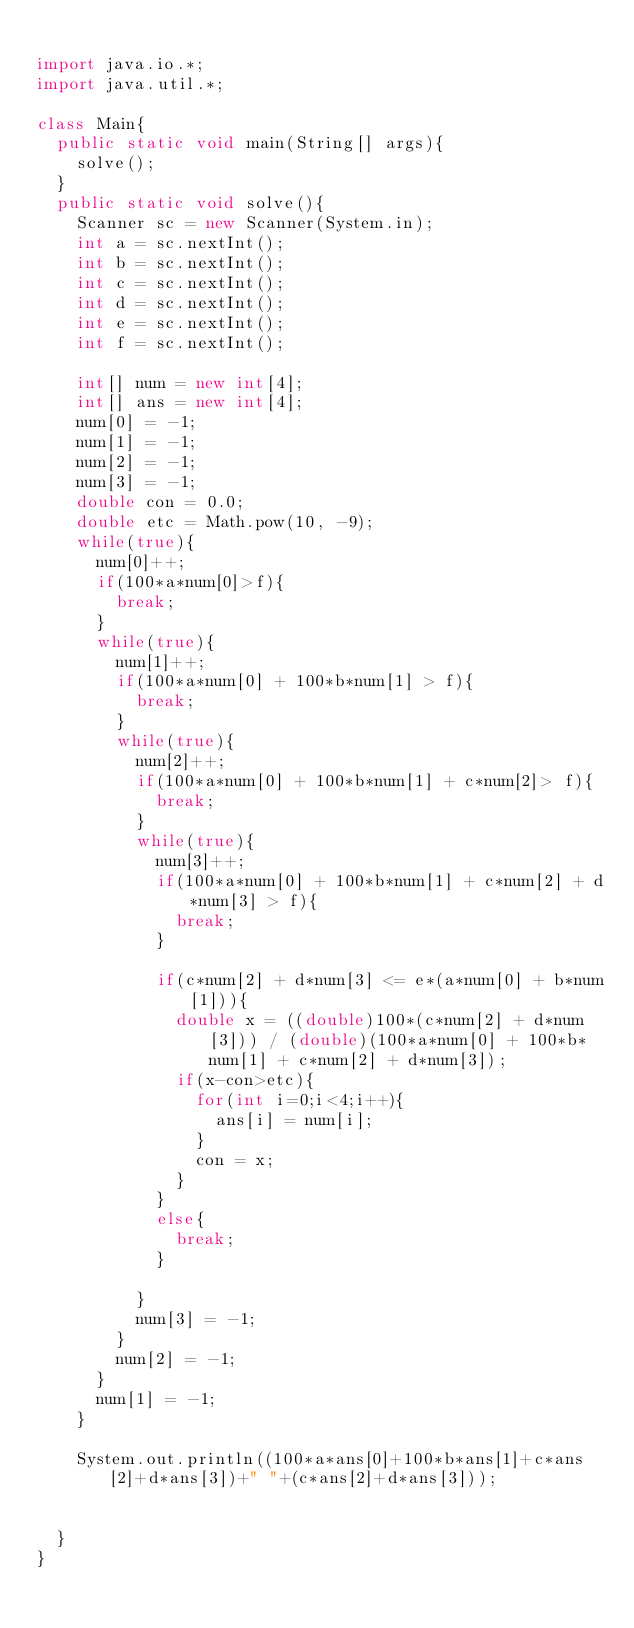<code> <loc_0><loc_0><loc_500><loc_500><_Java_>
import java.io.*;
import java.util.*;

class Main{
	public static void main(String[] args){
		solve();
	}
	public static void solve(){
		Scanner sc = new Scanner(System.in);
		int a = sc.nextInt();
		int b = sc.nextInt();
		int c = sc.nextInt();
		int d = sc.nextInt();
		int e = sc.nextInt();
		int f = sc.nextInt();

		int[] num = new int[4];
		int[] ans = new int[4];
		num[0] = -1;
		num[1] = -1;
		num[2] = -1;
		num[3] = -1;
		double con = 0.0;
		double etc = Math.pow(10, -9);
		while(true){
			num[0]++;
			if(100*a*num[0]>f){
				break;
			}
			while(true){
				num[1]++;
				if(100*a*num[0] + 100*b*num[1] > f){
					break;
				}
				while(true){
					num[2]++;
					if(100*a*num[0] + 100*b*num[1] + c*num[2]> f){
						break;
					}
					while(true){
						num[3]++;
						if(100*a*num[0] + 100*b*num[1] + c*num[2] + d*num[3] > f){
							break;
						}

						if(c*num[2] + d*num[3] <= e*(a*num[0] + b*num[1])){
							double x = ((double)100*(c*num[2] + d*num[3])) / (double)(100*a*num[0] + 100*b*num[1] + c*num[2] + d*num[3]);
							if(x-con>etc){
								for(int i=0;i<4;i++){
									ans[i] = num[i];
								}
								con = x;
							}
						}
						else{
							break;
						}

					}
					num[3] = -1;
				}
				num[2] = -1;
			}
			num[1] = -1;
		}

		System.out.println((100*a*ans[0]+100*b*ans[1]+c*ans[2]+d*ans[3])+" "+(c*ans[2]+d*ans[3]));


	}
}
</code> 